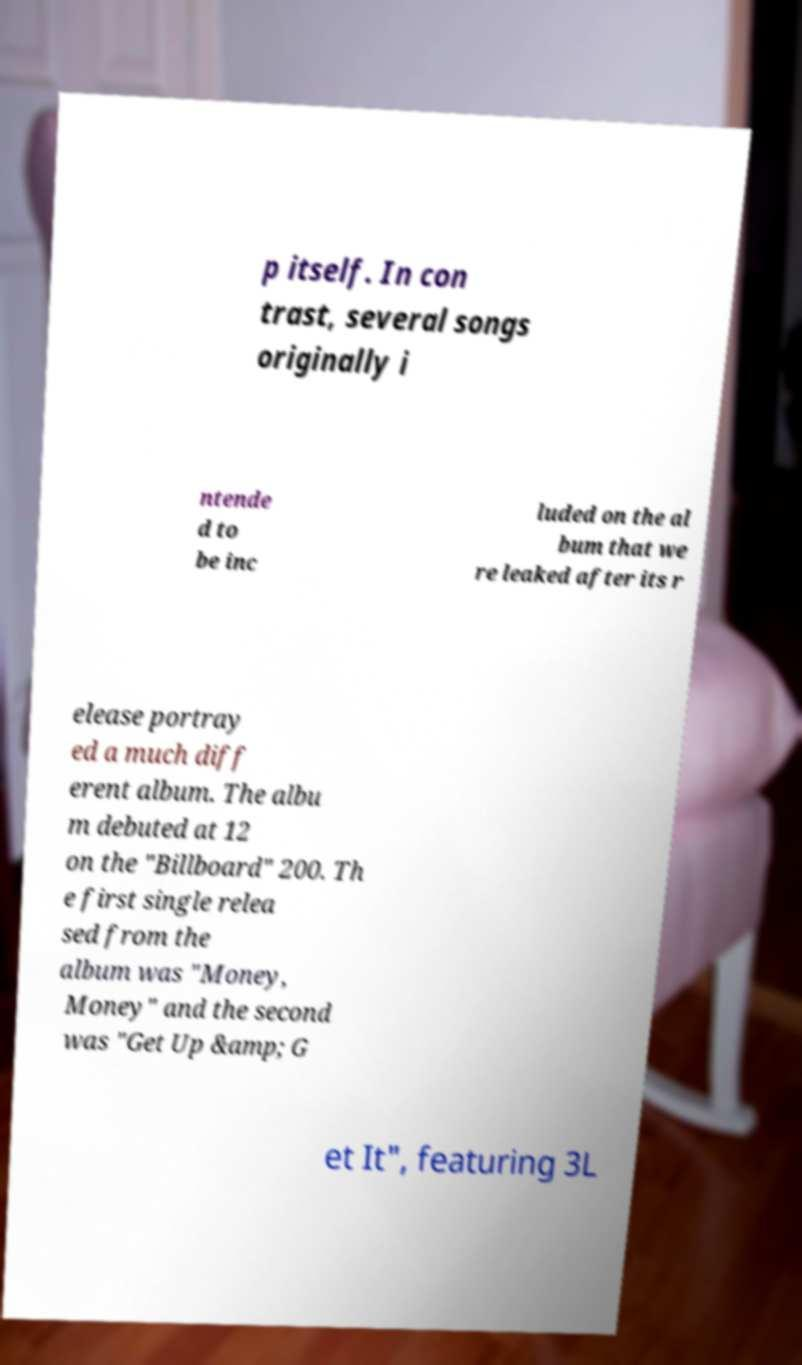What messages or text are displayed in this image? I need them in a readable, typed format. p itself. In con trast, several songs originally i ntende d to be inc luded on the al bum that we re leaked after its r elease portray ed a much diff erent album. The albu m debuted at 12 on the "Billboard" 200. Th e first single relea sed from the album was "Money, Money" and the second was "Get Up &amp; G et It", featuring 3L 